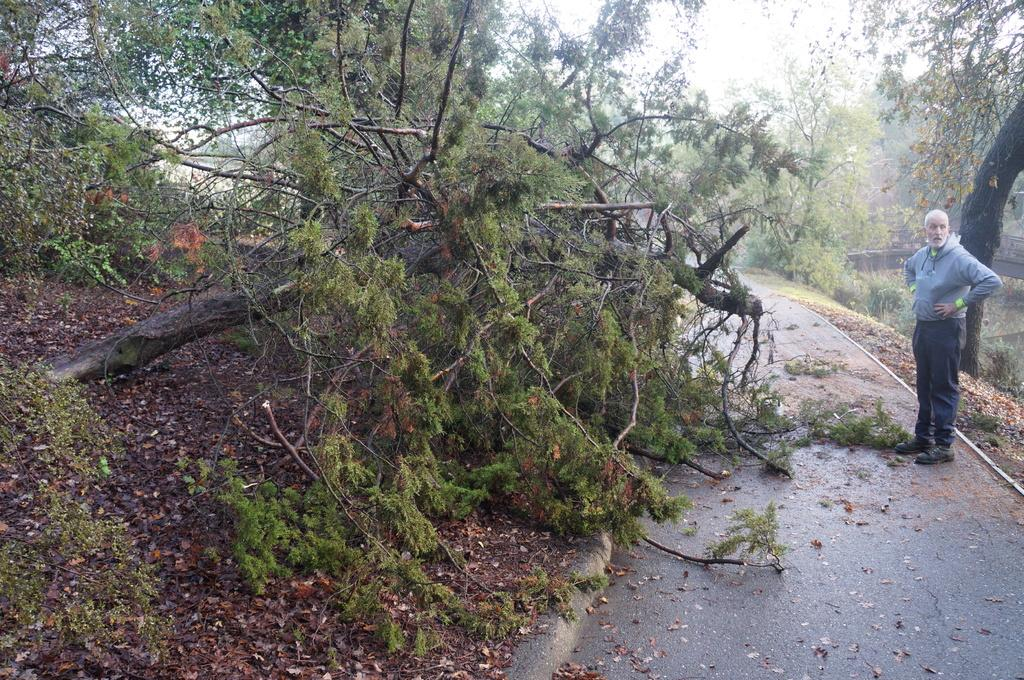What type of vegetation can be seen in the image? There are trees in the image. Can you describe the person in the image? The person is wearing a t-shirt, trousers, and shoes. What is the person wearing on their feet? The person is wearing shoes. How many tomatoes can be seen on the person's head in the image? There are no tomatoes present in the image, and the person is not wearing any on their head. What advice might the person's mom give them in the image? There is no reference to the person's mom in the image, so it's not possible to determine what advice she might give. 